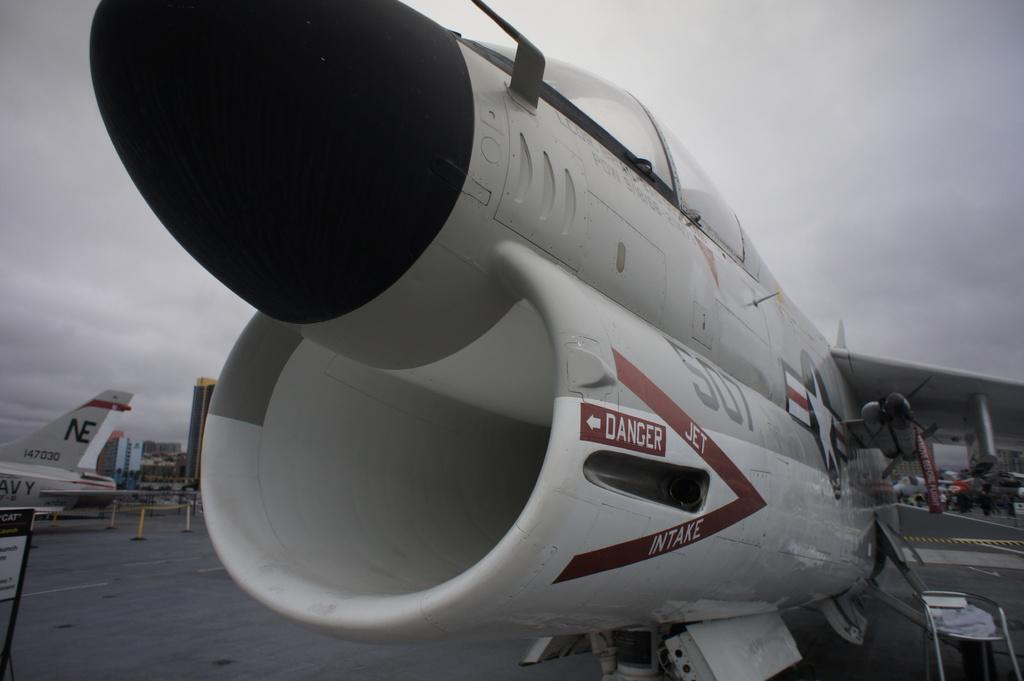<image>
Give a short and clear explanation of the subsequent image. the front of a jet with the words Danger and Intake on it 